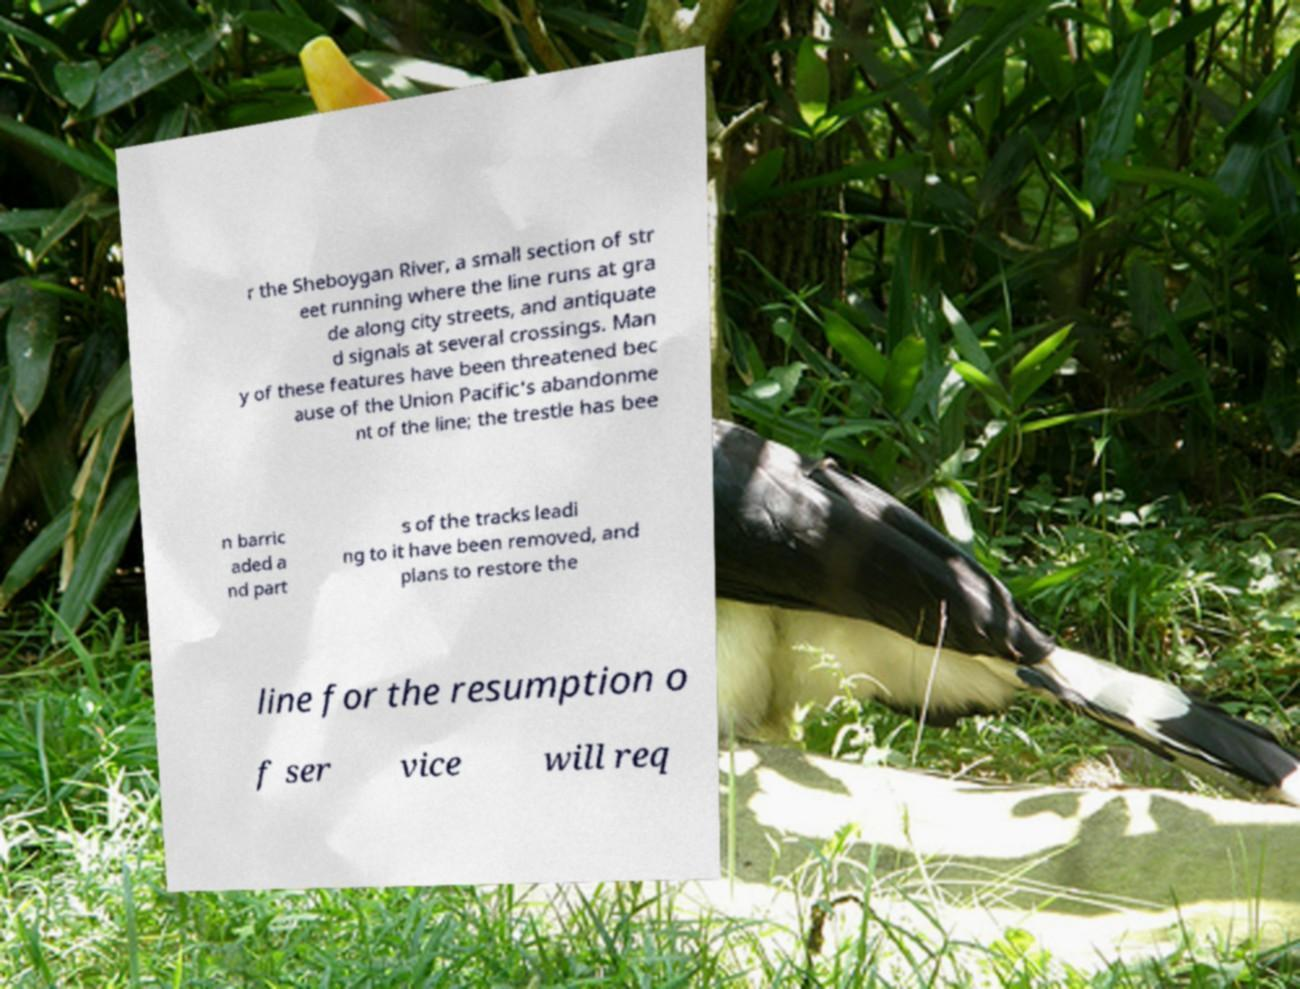There's text embedded in this image that I need extracted. Can you transcribe it verbatim? r the Sheboygan River, a small section of str eet running where the line runs at gra de along city streets, and antiquate d signals at several crossings. Man y of these features have been threatened bec ause of the Union Pacific's abandonme nt of the line; the trestle has bee n barric aded a nd part s of the tracks leadi ng to it have been removed, and plans to restore the line for the resumption o f ser vice will req 